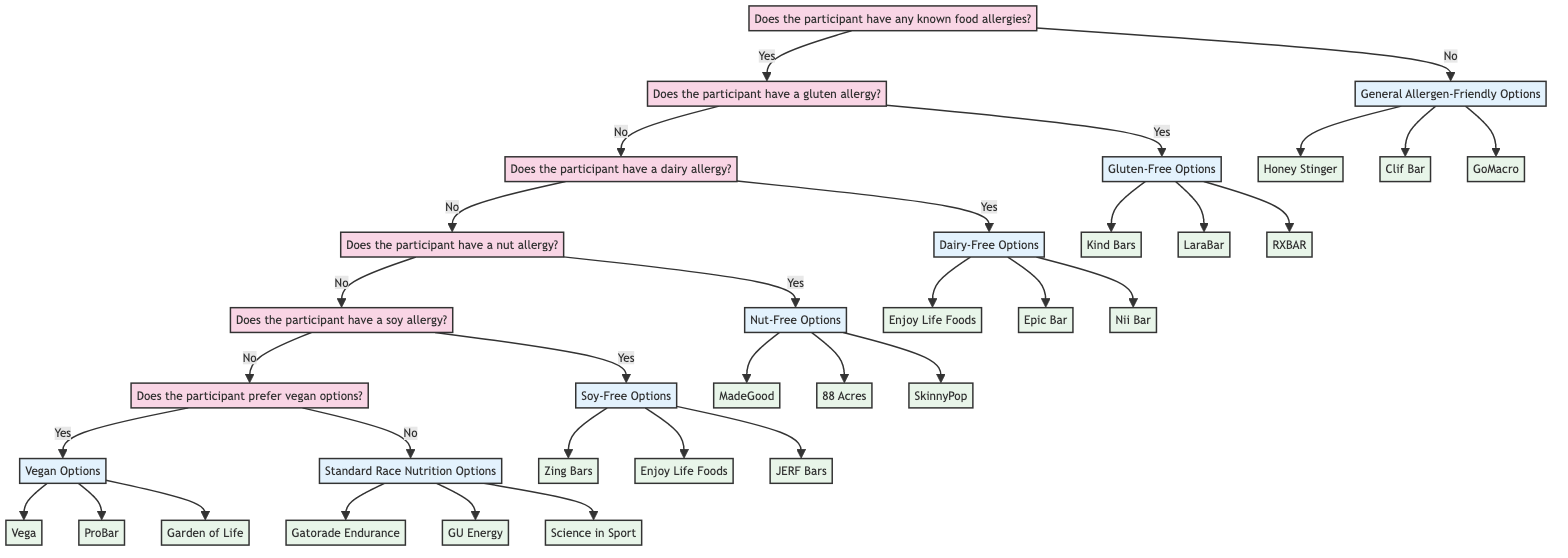Does the participant have any known food allergies? This is the starting question in the diagram, representing the first decision point regarding a participant's dietary restrictions.
Answer: Yes What is recommended if the participant has a gluten allergy? The flow from "Does the participant have a gluten allergy?" leads to a recommendation of "Gluten-Free Options," which includes specific brands for the participant.
Answer: Gluten-Free Options How many brands are listed under Dairy-Free Options? In the section for Dairy-Free Options, there are three brands mentioned: Enjoy Life Foods, Epic Bar, and Nii Bar. Counting these gives us a total.
Answer: 3 What follows if the participant does not have a nut allergy? The flow indicates that if the participant does not have a nut allergy, the next step is to ask if they have a soy allergy, which is the subsequent decision point.
Answer: Does the participant have a soy allergy? Which brand is listed under Soy-Free Options? Within the Soy-Free Options, three brands are provided, one of which is Zing Bars. This is a direct answer from the relevant section of the diagram.
Answer: Zing Bars What is the outcome if the participant prefers vegan options? The flow leads from the question of vegan preference to the recommendation of "Vegan Options," providing a clear outcome based on the participant's preference.
Answer: Vegan Options What does the diagram recommend if the participant has no known food allergies? If there are no known food allergies, the diagram directly recommends "General Allergen-Friendly Options," which specifies several suitable brands.
Answer: General Allergen-Friendly Options How many total decision points are there in the diagram? The diagram illustrates a total of six decision points leading to various recommendations, including the starting point and options regarding multiple allergies and preferences.
Answer: 6 What option is presented for participants who do not prefer vegan options? The decision tree indicates if the participant does not prefer vegan options, they receive a recommendation for "Standard Race Nutrition Options," providing guidance on what to provide.
Answer: Standard Race Nutrition Options 